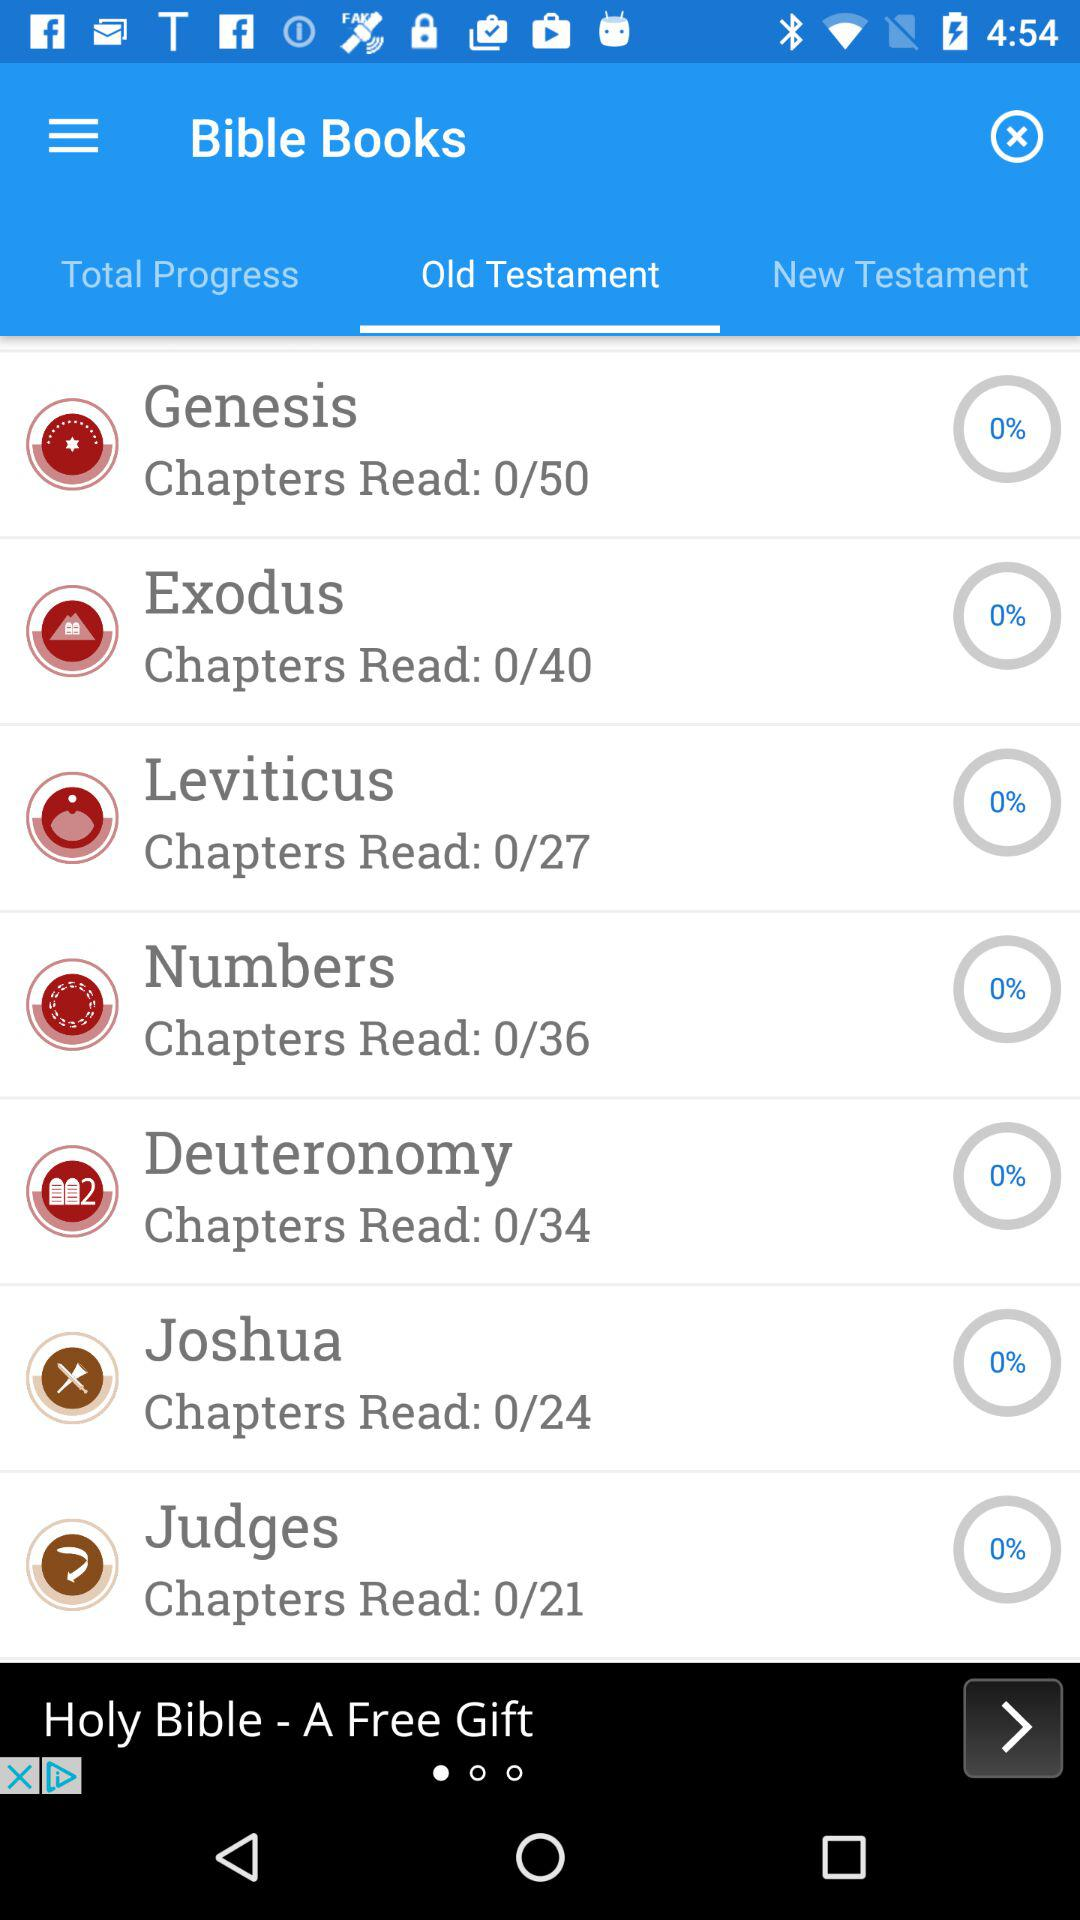How many chapters are shown in "Genesis"? There are 50 chapters shown in "Genesis". 